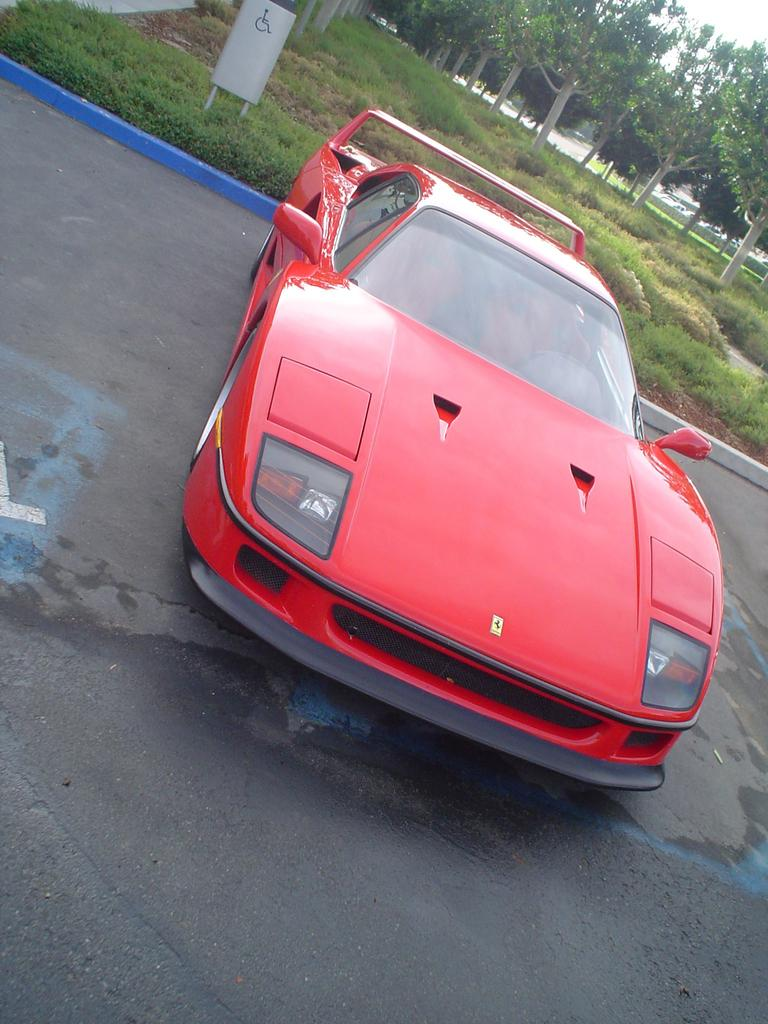What is the main subject in the center of the image? There is a car in the center of the image. What is located at the bottom of the image? There is a road at the bottom of the image. What can be seen in the background of the image? There are trees, grass, and some unspecified objects in the background of the image. What color are the eyes of the car in the image? Cars do not have eyes, so this question cannot be answered. 